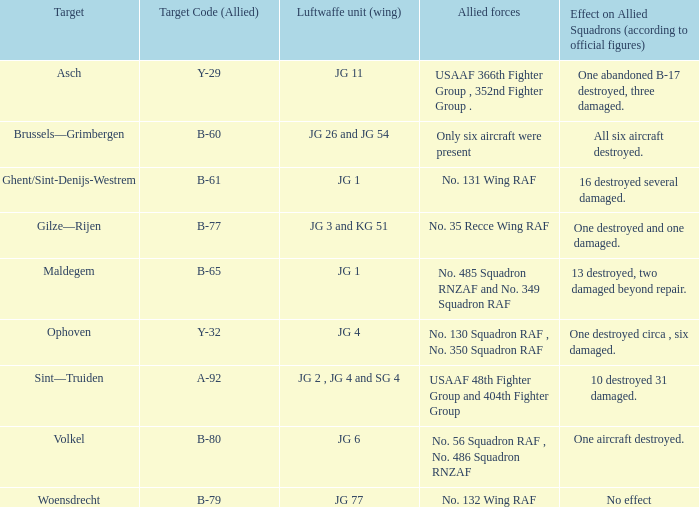Which allied force aimed at woensdrecht? No. 132 Wing RAF. 